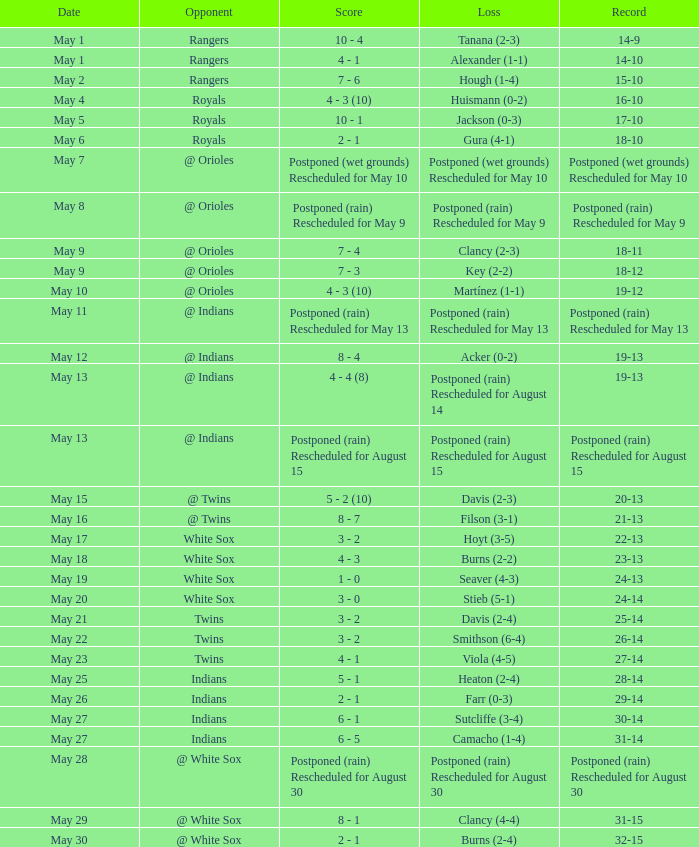What was the game's outcome against the indians when camacho experienced a loss with a 1-4 record? 31-14. 